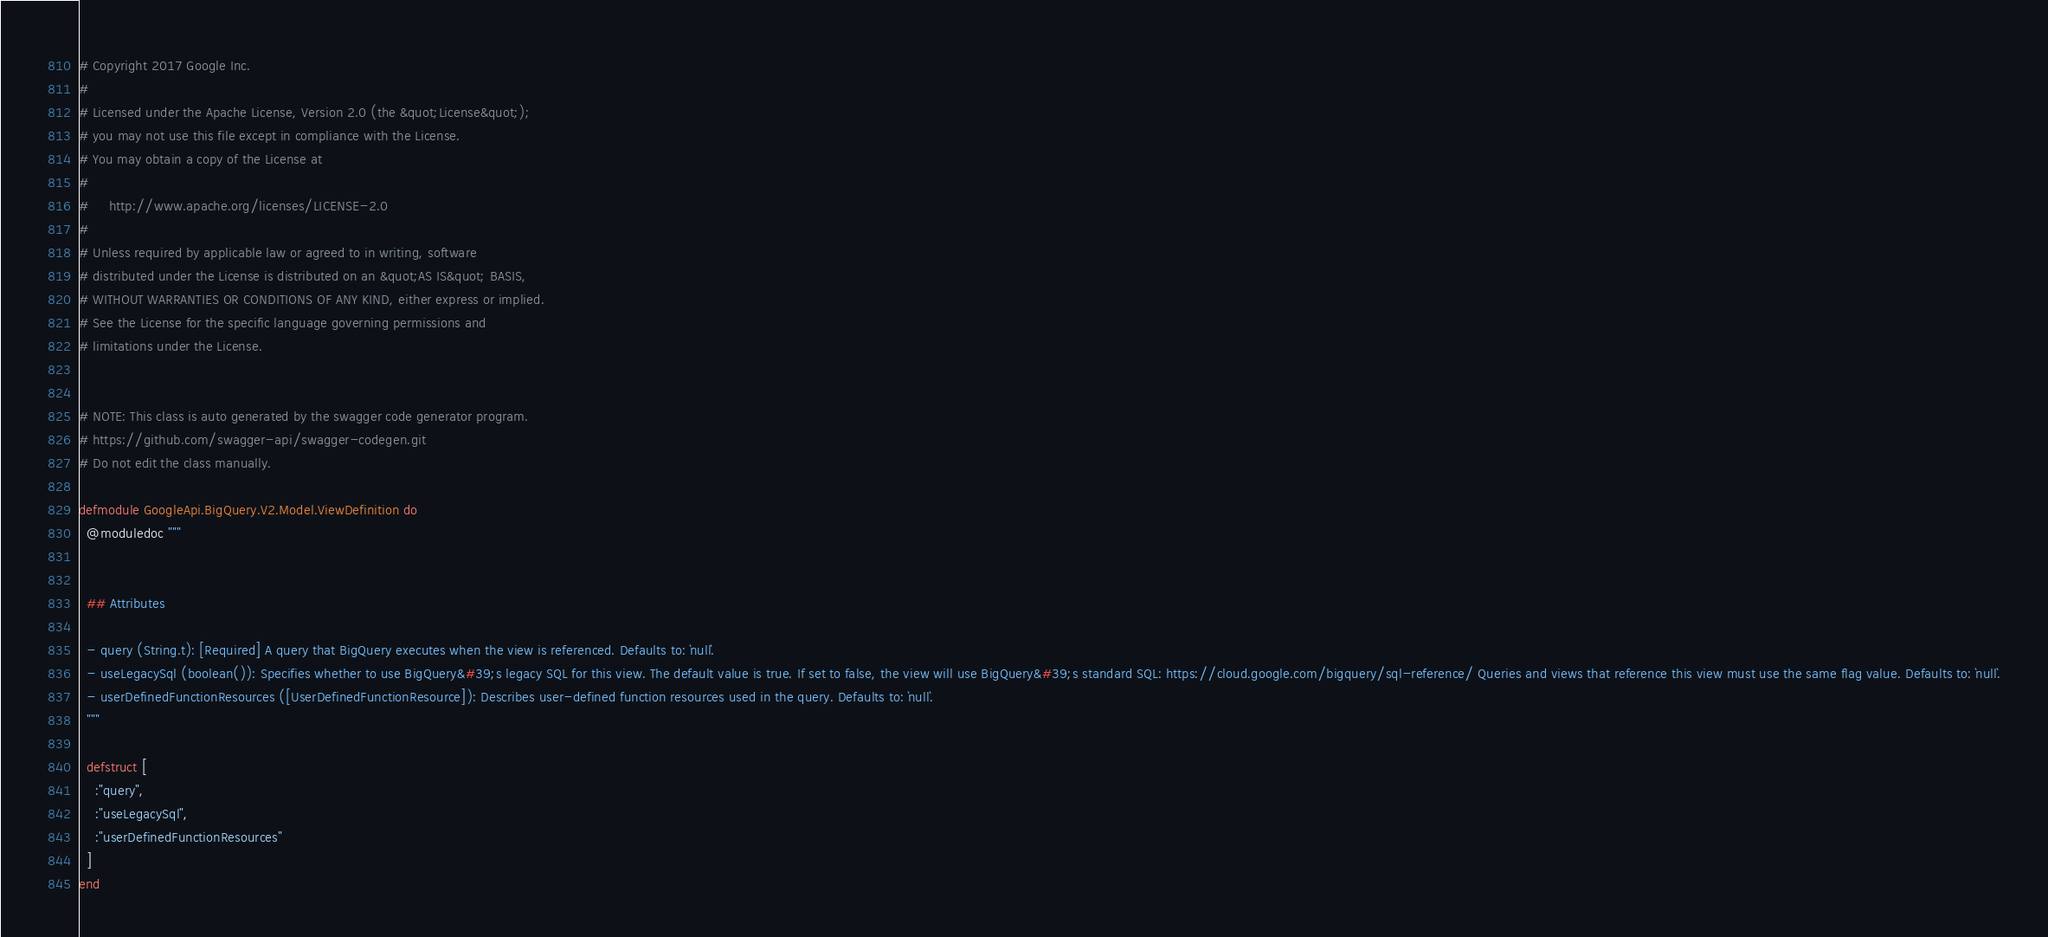Convert code to text. <code><loc_0><loc_0><loc_500><loc_500><_Elixir_># Copyright 2017 Google Inc.
#
# Licensed under the Apache License, Version 2.0 (the &quot;License&quot;);
# you may not use this file except in compliance with the License.
# You may obtain a copy of the License at
#
#     http://www.apache.org/licenses/LICENSE-2.0
#
# Unless required by applicable law or agreed to in writing, software
# distributed under the License is distributed on an &quot;AS IS&quot; BASIS,
# WITHOUT WARRANTIES OR CONDITIONS OF ANY KIND, either express or implied.
# See the License for the specific language governing permissions and
# limitations under the License.


# NOTE: This class is auto generated by the swagger code generator program.
# https://github.com/swagger-api/swagger-codegen.git
# Do not edit the class manually.

defmodule GoogleApi.BigQuery.V2.Model.ViewDefinition do
  @moduledoc """
  

  ## Attributes

  - query (String.t): [Required] A query that BigQuery executes when the view is referenced. Defaults to: `null`.
  - useLegacySql (boolean()): Specifies whether to use BigQuery&#39;s legacy SQL for this view. The default value is true. If set to false, the view will use BigQuery&#39;s standard SQL: https://cloud.google.com/bigquery/sql-reference/ Queries and views that reference this view must use the same flag value. Defaults to: `null`.
  - userDefinedFunctionResources ([UserDefinedFunctionResource]): Describes user-defined function resources used in the query. Defaults to: `null`.
  """

  defstruct [
    :"query",
    :"useLegacySql",
    :"userDefinedFunctionResources"
  ]
end
</code> 